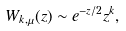Convert formula to latex. <formula><loc_0><loc_0><loc_500><loc_500>W _ { k , \mu } ( z ) \sim e ^ { - z / 2 } z ^ { k } ,</formula> 